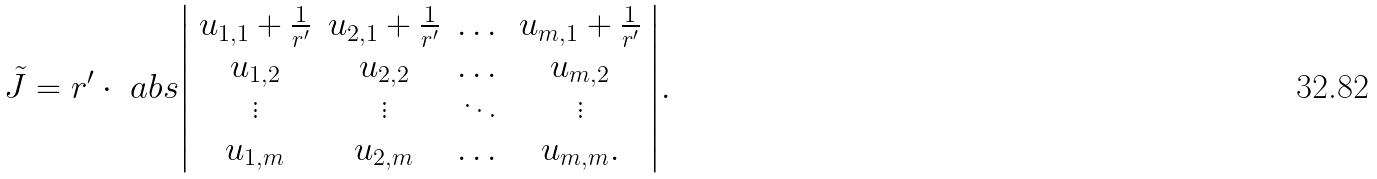Convert formula to latex. <formula><loc_0><loc_0><loc_500><loc_500>\tilde { J } & = r ^ { \prime } \cdot \ a b s { \left | \begin{array} { c c c c } u _ { 1 , 1 } + \frac { 1 } { r ^ { \prime } } & u _ { 2 , 1 } + \frac { 1 } { r ^ { \prime } } & \dots & u _ { m , 1 } + \frac { 1 } { r ^ { \prime } } \\ u _ { 1 , 2 } & u _ { 2 , 2 } & \dots & u _ { m , 2 } \\ \vdots & \vdots & \ddots & \vdots \\ u _ { 1 , m } & u _ { 2 , m } & \dots & u _ { m , m } . \end{array} \right | } .</formula> 